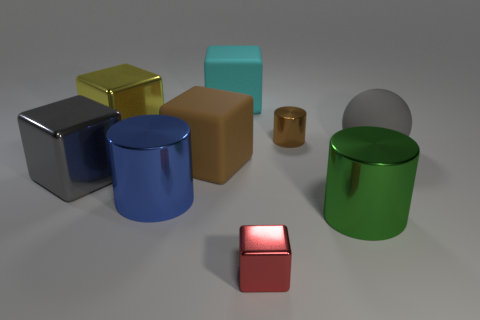The small metal block has what color?
Offer a very short reply. Red. There is a brown matte thing; are there any gray matte things in front of it?
Keep it short and to the point. No. There is a large green object; is its shape the same as the rubber thing that is behind the big yellow metallic thing?
Your answer should be compact. No. How many other objects are there of the same material as the red object?
Your answer should be compact. 5. What is the color of the block that is in front of the metallic cylinder to the left of the brown thing that is on the left side of the tiny red block?
Ensure brevity in your answer.  Red. There is a tiny shiny object that is in front of the brown object left of the tiny red shiny cube; what shape is it?
Your answer should be very brief. Cube. Is the number of large cyan objects that are left of the large cyan matte thing greater than the number of large red metallic spheres?
Your answer should be very brief. No. Is the shape of the large gray object behind the gray shiny thing the same as  the big green shiny object?
Your answer should be very brief. No. Are there any tiny gray rubber things that have the same shape as the blue thing?
Make the answer very short. No. What number of objects are either rubber cubes left of the large cyan rubber object or big cyan cylinders?
Provide a succinct answer. 1. 